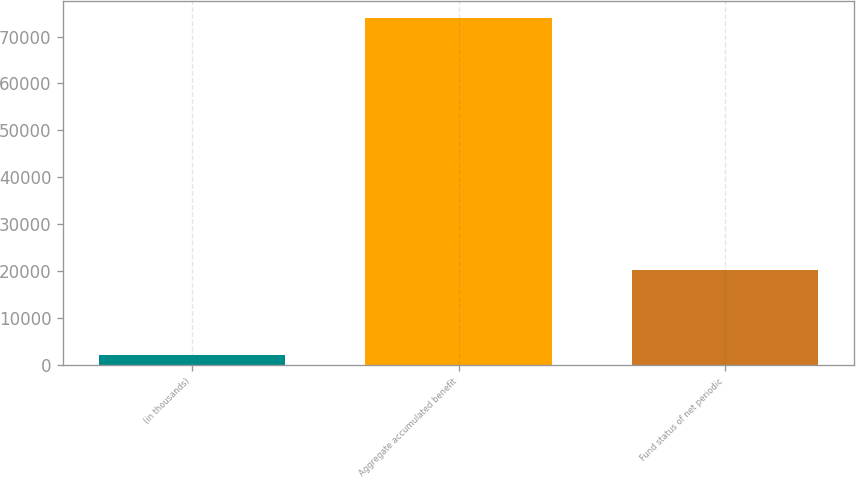<chart> <loc_0><loc_0><loc_500><loc_500><bar_chart><fcel>(in thousands)<fcel>Aggregate accumulated benefit<fcel>Fund status of net periodic<nl><fcel>2001<fcel>73868<fcel>20298<nl></chart> 